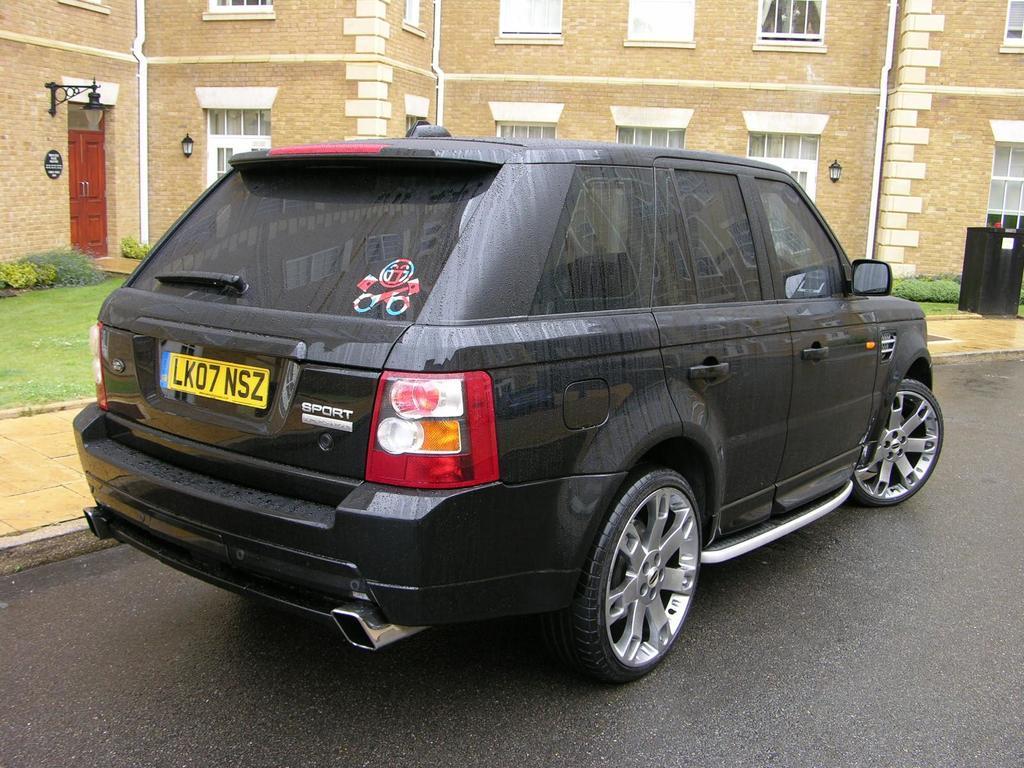Could you give a brief overview of what you see in this image? This is a black car, which is parked on the road. I can see a building with the windows and a door. This is a lamp, which is attached to the wall. These are the small bushes. On the right side of the image, that looks like an object, which is black in color. Here is the grass. 